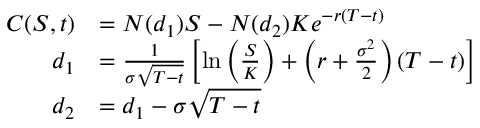Convert formula to latex. <formula><loc_0><loc_0><loc_500><loc_500>{ \begin{array} { r l } { C ( S , t ) } & { = N ( d _ { 1 } ) S - N ( d _ { 2 } ) K e ^ { - r ( T - t ) } } \\ { d _ { 1 } } & { = { \frac { 1 } { \sigma { \sqrt { T - t } } } } \left [ \ln \left ( { \frac { S } { K } } \right ) + \left ( r + { \frac { \sigma ^ { 2 } } { 2 } } \right ) ( T - t ) \right ] } \\ { d _ { 2 } } & { = d _ { 1 } - \sigma { \sqrt { T - t } } } \end{array} }</formula> 